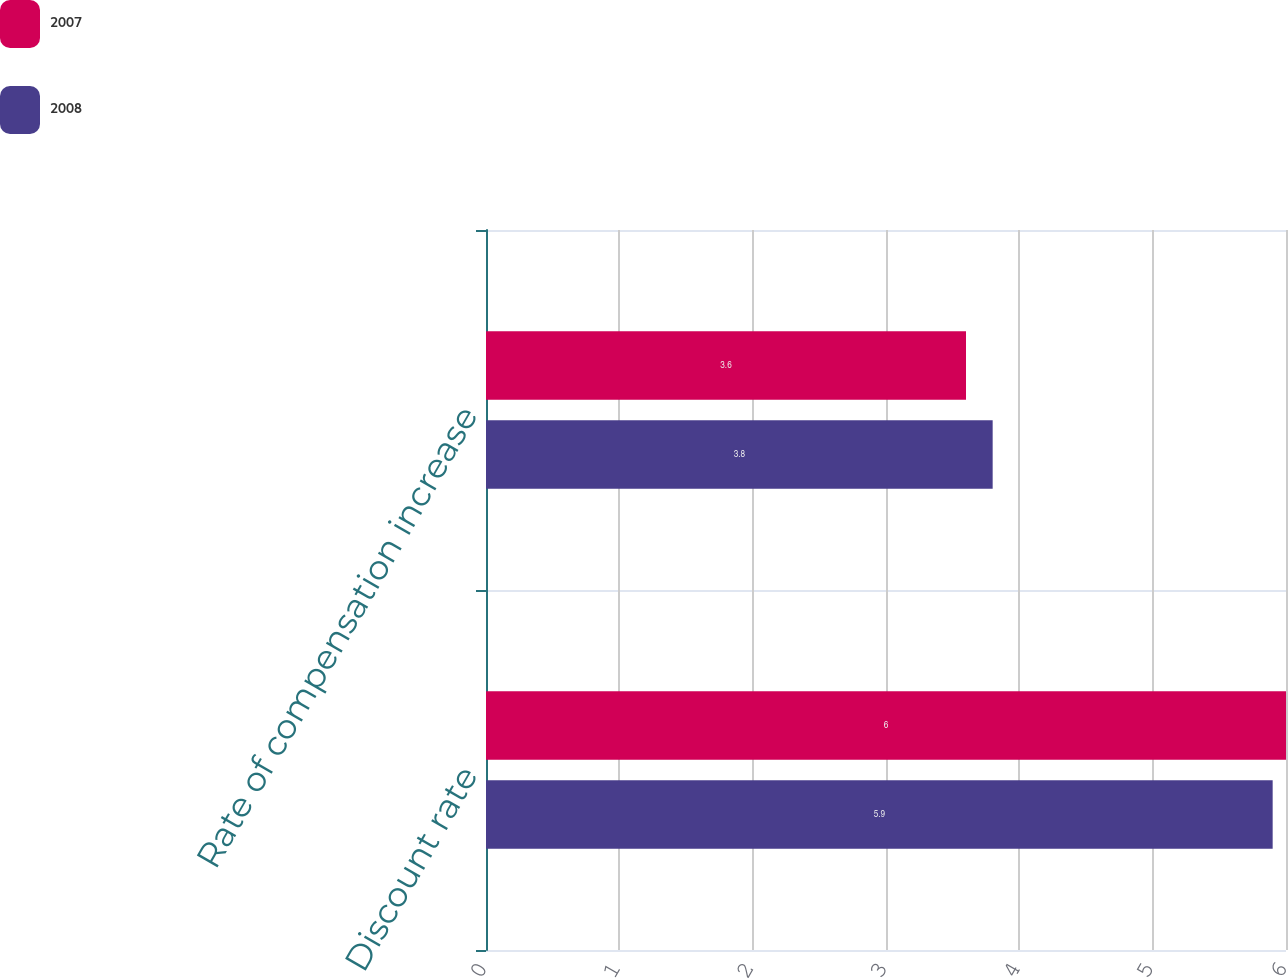Convert chart. <chart><loc_0><loc_0><loc_500><loc_500><stacked_bar_chart><ecel><fcel>Discount rate<fcel>Rate of compensation increase<nl><fcel>2007<fcel>6<fcel>3.6<nl><fcel>2008<fcel>5.9<fcel>3.8<nl></chart> 